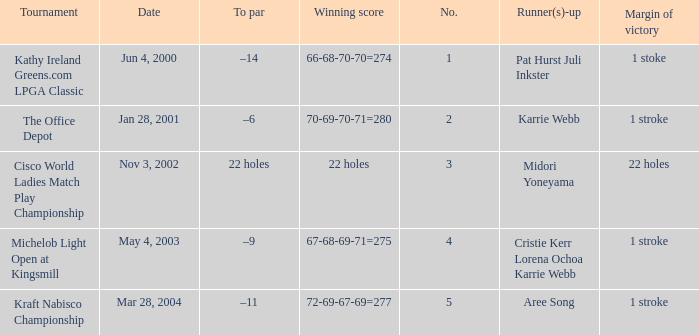Where is the margin of victory dated mar 28, 2004? 1 stroke. 